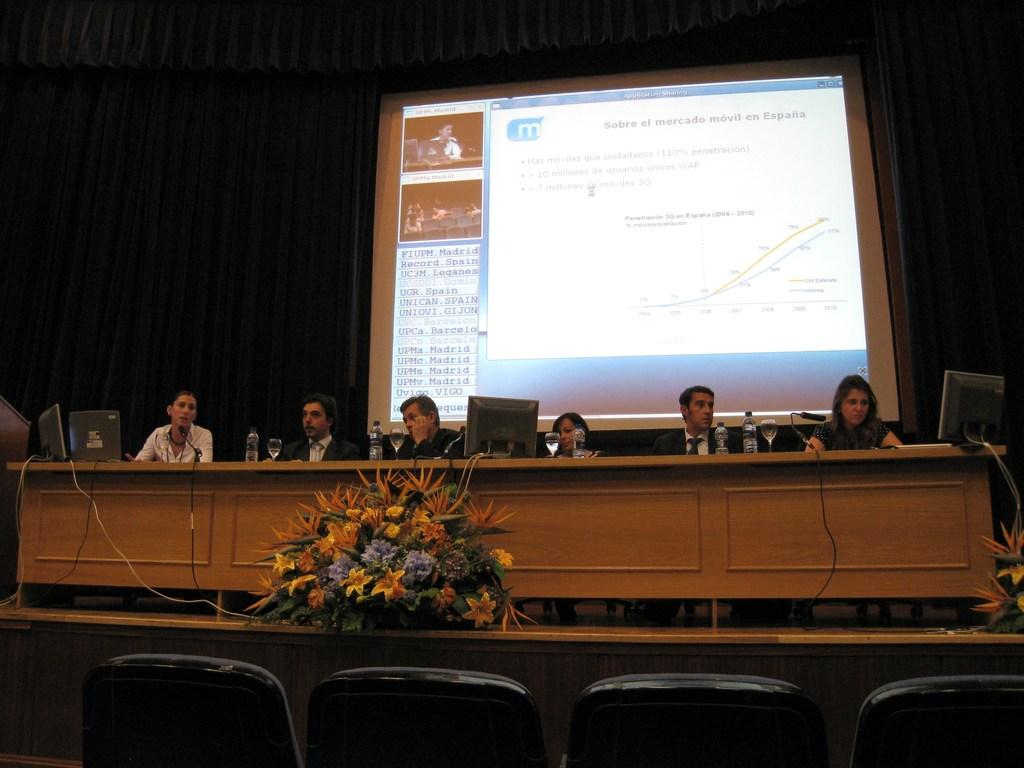What are the people in the image doing? There are persons sitting in the image, which suggests they might be engaged in an activity or conversation. What objects can be seen on the table in the image? There are bottles, glasses, monitors, and microphones on the table. What can be seen in the background of the image? There is a screen and a curtain in the background. What type of furniture is present in the image? There are chairs in the image. Are there any decorative elements in the image? Yes, there are flowers in the image. What type of crate is visible in the image? There is no crate present in the image. Can you tell me how many hydrant's color in the image? There is no hydrant present in the image. 